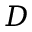<formula> <loc_0><loc_0><loc_500><loc_500>D</formula> 